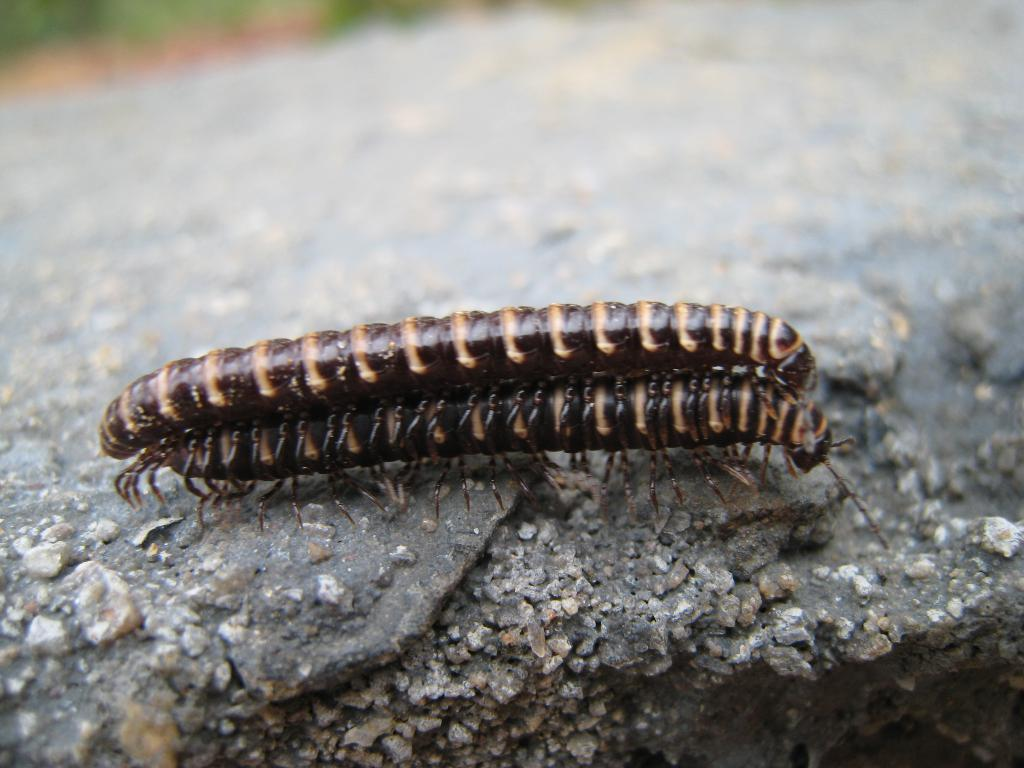How many insects can be seen in the image? There are two insects present in the image. Where are the insects located in the image? The insects are on the surface in the image. What type of account does the insect on the left have in the image? There is no indication of an account or any financial aspect in the image, as it features two insects on a surface. 